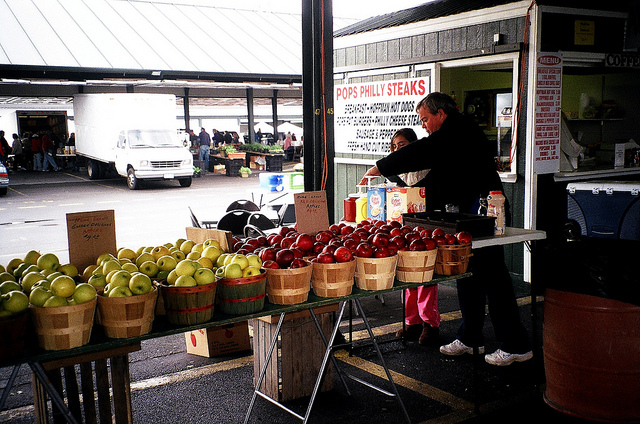Please identify all text content in this image. POPS PHILLY STEAKS 